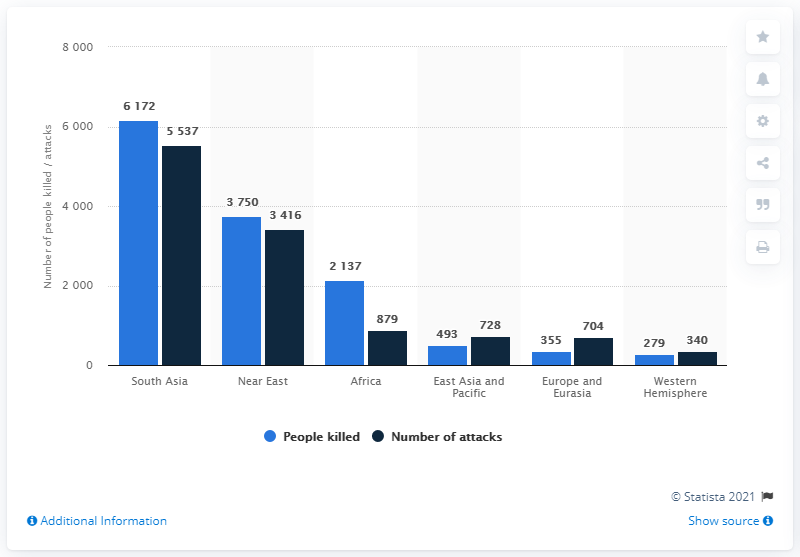Mention a couple of crucial points in this snapshot. In 2010, a total of 879 terrorist attacks were recorded in Africa. 